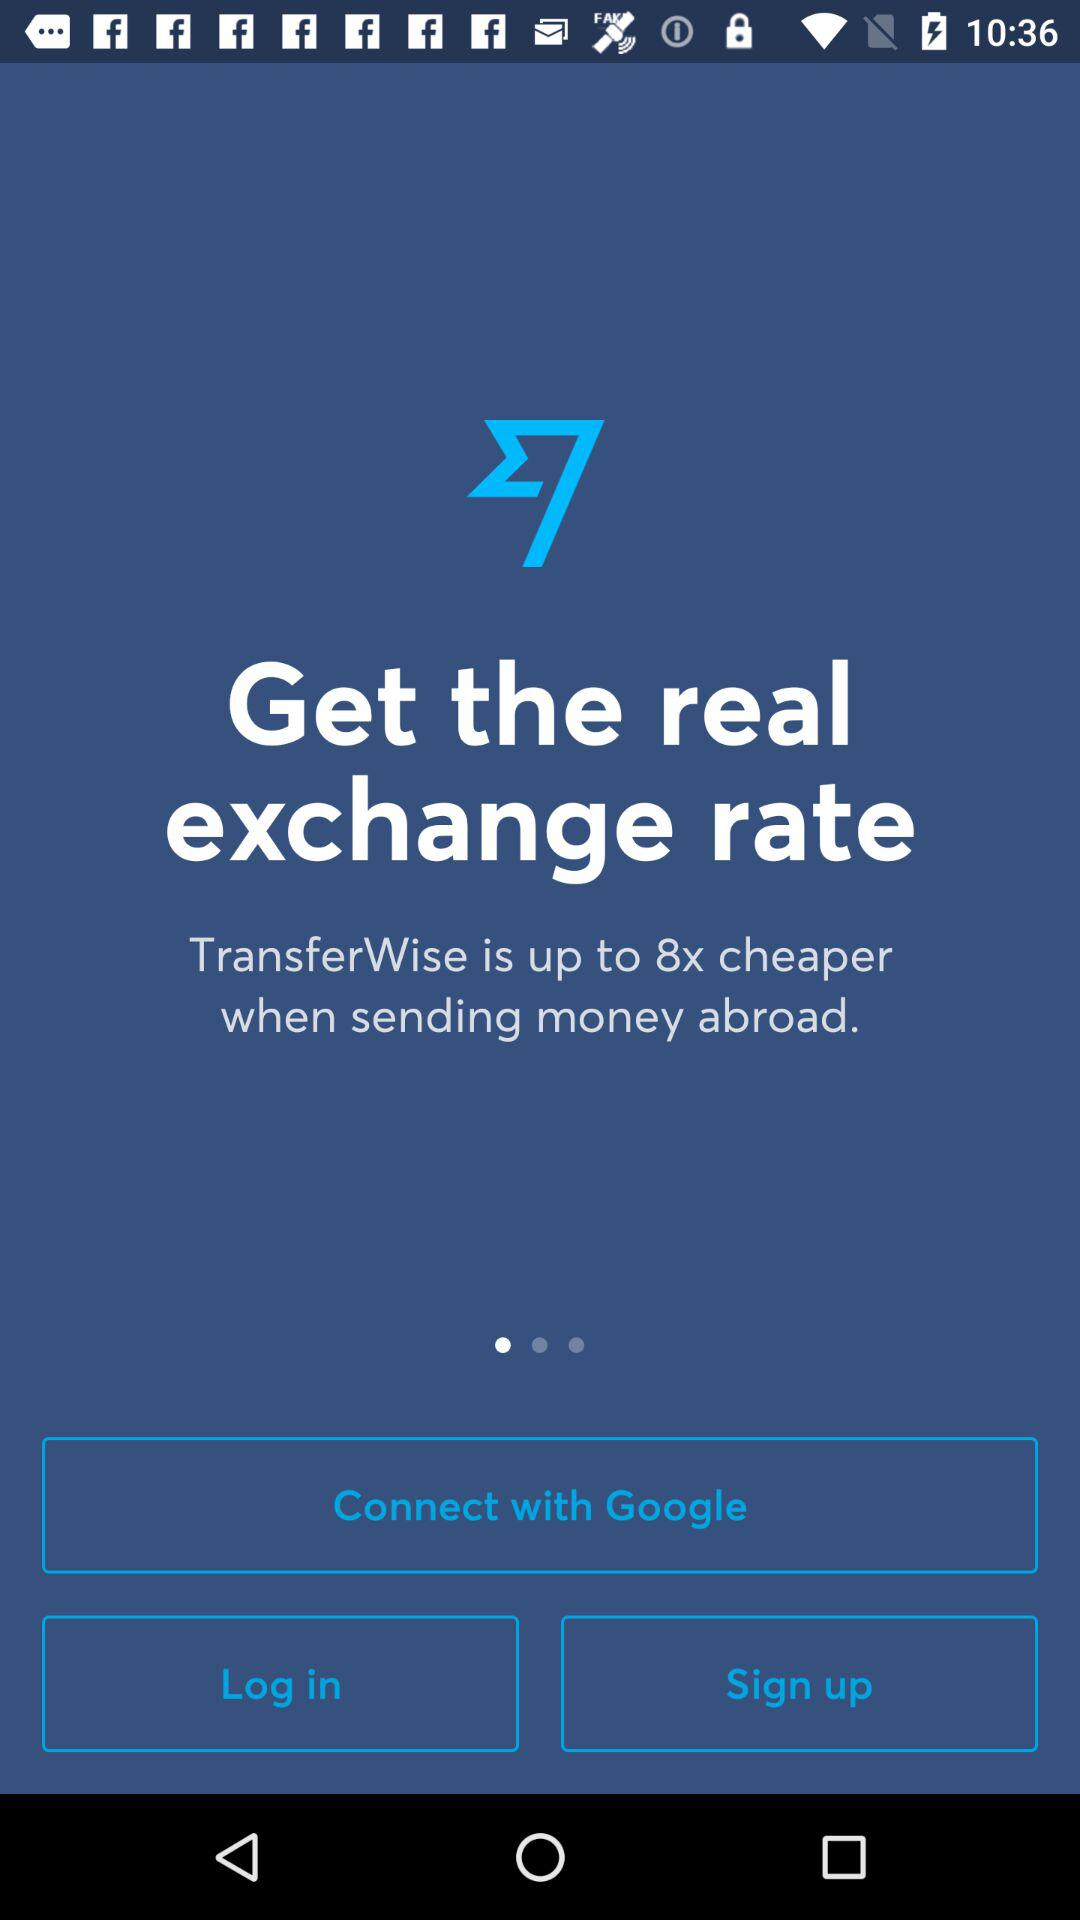What is the app name? The app name is "Wise". 